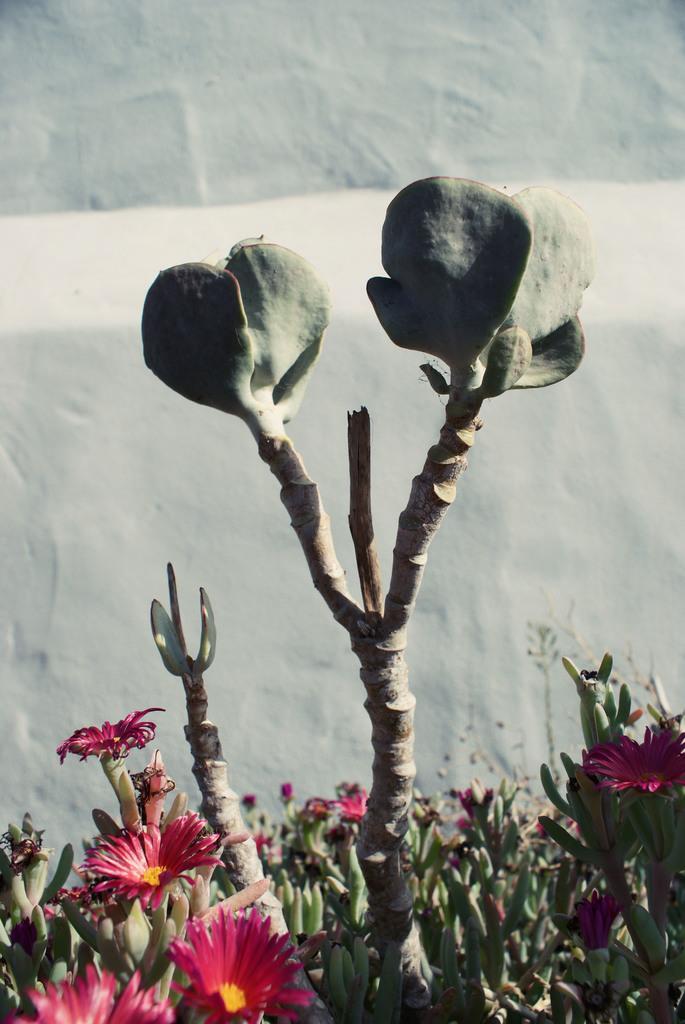Could you give a brief overview of what you see in this image? There are beautiful flower plants and in between them there is a non flowering plant and in the background there is a white wall. 